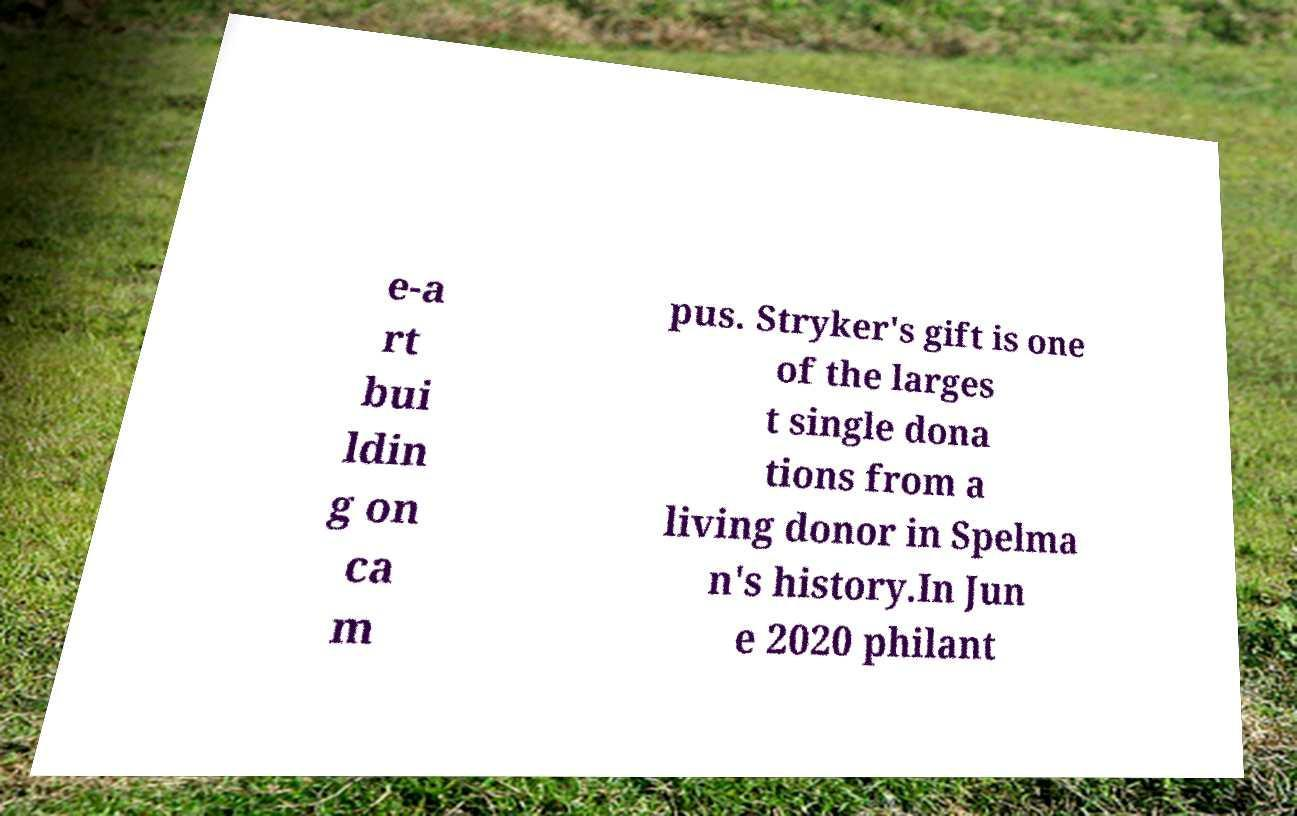Could you extract and type out the text from this image? e-a rt bui ldin g on ca m pus. Stryker's gift is one of the larges t single dona tions from a living donor in Spelma n's history.In Jun e 2020 philant 